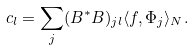Convert formula to latex. <formula><loc_0><loc_0><loc_500><loc_500>c _ { l } = \sum _ { j } ( B ^ { * } B ) _ { j l } \langle f , \Phi _ { j } \rangle _ { N } .</formula> 